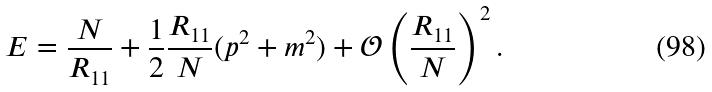Convert formula to latex. <formula><loc_0><loc_0><loc_500><loc_500>E = \frac { N } { R _ { 1 1 } } + \frac { 1 } { 2 } \frac { R _ { 1 1 } } { N } ( p ^ { 2 } + m ^ { 2 } ) + \mathcal { O } \left ( \frac { R _ { 1 1 } } { N } \right ) ^ { 2 } .</formula> 